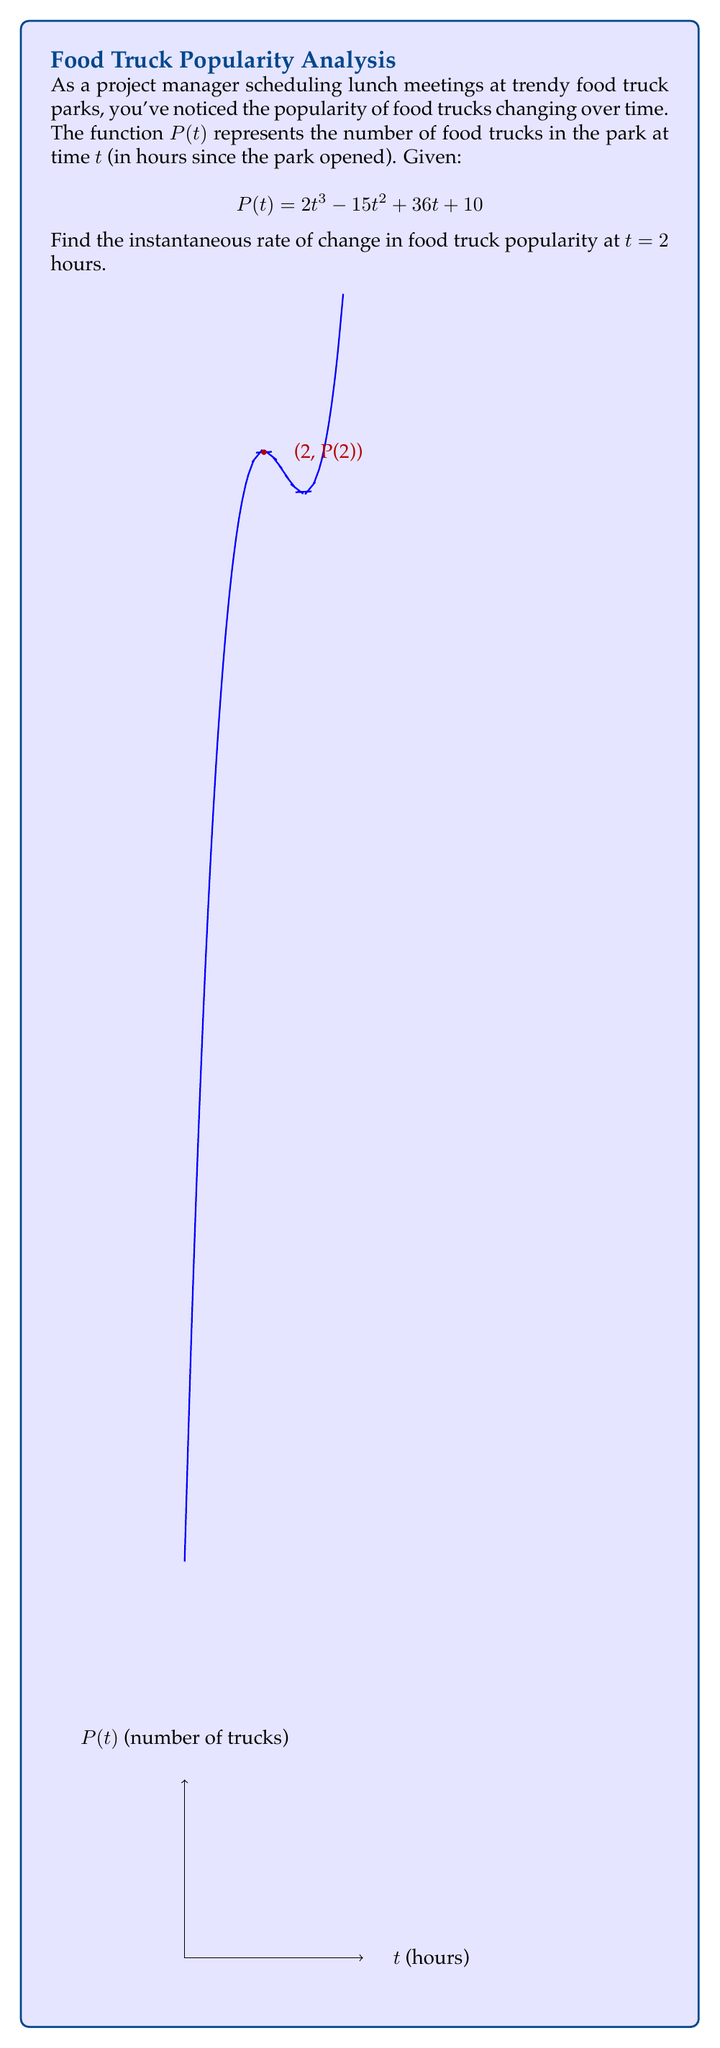Help me with this question. To find the instantaneous rate of change at $t = 2$, we need to calculate the derivative of $P(t)$ and evaluate it at $t = 2$. Here's the step-by-step process:

1) First, let's find the derivative of $P(t)$:
   $$P'(t) = \frac{d}{dt}(2t^3 - 15t^2 + 36t + 10)$$
   
2) Using the power rule and constant rule:
   $$P'(t) = 6t^2 - 30t + 36$$

3) Now, we evaluate $P'(t)$ at $t = 2$:
   $$P'(2) = 6(2)^2 - 30(2) + 36$$

4) Simplify:
   $$P'(2) = 6(4) - 60 + 36$$
   $$P'(2) = 24 - 60 + 36$$
   $$P'(2) = 0$$

The instantaneous rate of change at $t = 2$ is 0 food trucks per hour.
Answer: 0 food trucks per hour 